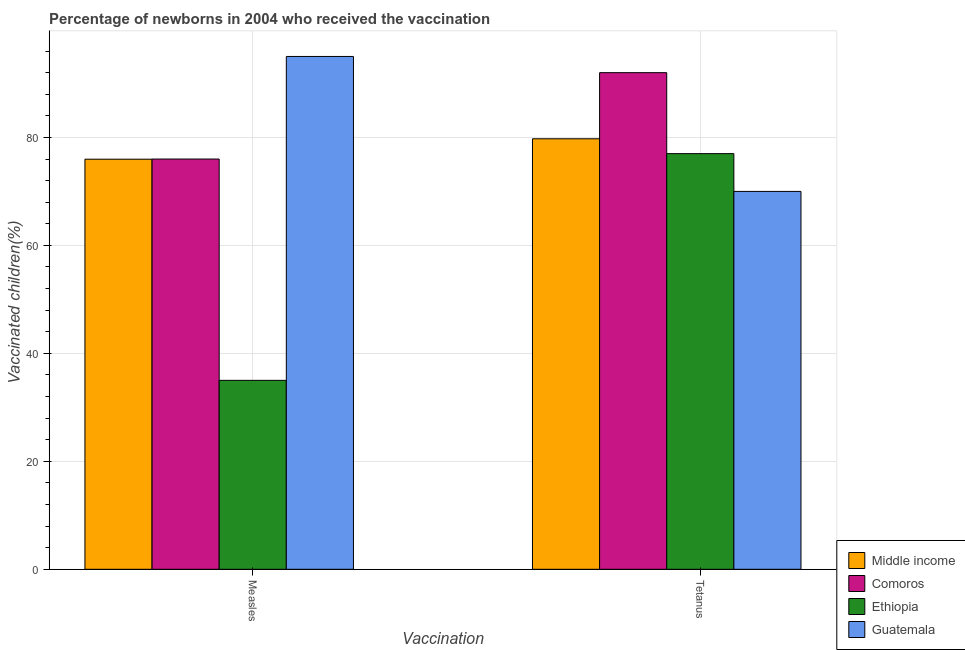How many groups of bars are there?
Your answer should be very brief. 2. Are the number of bars per tick equal to the number of legend labels?
Offer a terse response. Yes. What is the label of the 2nd group of bars from the left?
Your answer should be compact. Tetanus. What is the percentage of newborns who received vaccination for tetanus in Guatemala?
Offer a terse response. 70. Across all countries, what is the maximum percentage of newborns who received vaccination for tetanus?
Provide a short and direct response. 92. Across all countries, what is the minimum percentage of newborns who received vaccination for measles?
Provide a succinct answer. 35. In which country was the percentage of newborns who received vaccination for tetanus maximum?
Offer a very short reply. Comoros. In which country was the percentage of newborns who received vaccination for measles minimum?
Your answer should be very brief. Ethiopia. What is the total percentage of newborns who received vaccination for measles in the graph?
Provide a short and direct response. 281.97. What is the difference between the percentage of newborns who received vaccination for measles in Guatemala and that in Ethiopia?
Ensure brevity in your answer.  60. What is the difference between the percentage of newborns who received vaccination for tetanus in Comoros and the percentage of newborns who received vaccination for measles in Middle income?
Provide a succinct answer. 16.03. What is the average percentage of newborns who received vaccination for tetanus per country?
Keep it short and to the point. 79.69. In how many countries, is the percentage of newborns who received vaccination for tetanus greater than 36 %?
Offer a terse response. 4. What is the ratio of the percentage of newborns who received vaccination for measles in Ethiopia to that in Guatemala?
Provide a short and direct response. 0.37. Is the percentage of newborns who received vaccination for tetanus in Ethiopia less than that in Middle income?
Your answer should be very brief. Yes. In how many countries, is the percentage of newborns who received vaccination for measles greater than the average percentage of newborns who received vaccination for measles taken over all countries?
Provide a short and direct response. 3. What does the 3rd bar from the right in Tetanus represents?
Provide a short and direct response. Comoros. How many bars are there?
Provide a short and direct response. 8. How many countries are there in the graph?
Keep it short and to the point. 4. What is the difference between two consecutive major ticks on the Y-axis?
Offer a terse response. 20. Does the graph contain grids?
Make the answer very short. Yes. Where does the legend appear in the graph?
Make the answer very short. Bottom right. How many legend labels are there?
Ensure brevity in your answer.  4. What is the title of the graph?
Give a very brief answer. Percentage of newborns in 2004 who received the vaccination. Does "European Union" appear as one of the legend labels in the graph?
Give a very brief answer. No. What is the label or title of the X-axis?
Offer a very short reply. Vaccination. What is the label or title of the Y-axis?
Your answer should be compact. Vaccinated children(%)
. What is the Vaccinated children(%)
 of Middle income in Measles?
Ensure brevity in your answer.  75.97. What is the Vaccinated children(%)
 in Comoros in Measles?
Provide a short and direct response. 76. What is the Vaccinated children(%)
 in Ethiopia in Measles?
Provide a succinct answer. 35. What is the Vaccinated children(%)
 of Guatemala in Measles?
Your answer should be very brief. 95. What is the Vaccinated children(%)
 in Middle income in Tetanus?
Provide a succinct answer. 79.75. What is the Vaccinated children(%)
 in Comoros in Tetanus?
Offer a very short reply. 92. What is the Vaccinated children(%)
 of Ethiopia in Tetanus?
Your answer should be compact. 77. Across all Vaccination, what is the maximum Vaccinated children(%)
 of Middle income?
Offer a terse response. 79.75. Across all Vaccination, what is the maximum Vaccinated children(%)
 in Comoros?
Give a very brief answer. 92. Across all Vaccination, what is the maximum Vaccinated children(%)
 in Guatemala?
Keep it short and to the point. 95. Across all Vaccination, what is the minimum Vaccinated children(%)
 of Middle income?
Keep it short and to the point. 75.97. What is the total Vaccinated children(%)
 of Middle income in the graph?
Your answer should be compact. 155.72. What is the total Vaccinated children(%)
 of Comoros in the graph?
Your answer should be very brief. 168. What is the total Vaccinated children(%)
 of Ethiopia in the graph?
Your response must be concise. 112. What is the total Vaccinated children(%)
 in Guatemala in the graph?
Ensure brevity in your answer.  165. What is the difference between the Vaccinated children(%)
 in Middle income in Measles and that in Tetanus?
Your answer should be compact. -3.78. What is the difference between the Vaccinated children(%)
 of Ethiopia in Measles and that in Tetanus?
Offer a terse response. -42. What is the difference between the Vaccinated children(%)
 in Middle income in Measles and the Vaccinated children(%)
 in Comoros in Tetanus?
Your answer should be compact. -16.03. What is the difference between the Vaccinated children(%)
 of Middle income in Measles and the Vaccinated children(%)
 of Ethiopia in Tetanus?
Make the answer very short. -1.03. What is the difference between the Vaccinated children(%)
 of Middle income in Measles and the Vaccinated children(%)
 of Guatemala in Tetanus?
Your response must be concise. 5.97. What is the difference between the Vaccinated children(%)
 of Ethiopia in Measles and the Vaccinated children(%)
 of Guatemala in Tetanus?
Your answer should be very brief. -35. What is the average Vaccinated children(%)
 of Middle income per Vaccination?
Ensure brevity in your answer.  77.86. What is the average Vaccinated children(%)
 in Guatemala per Vaccination?
Offer a very short reply. 82.5. What is the difference between the Vaccinated children(%)
 in Middle income and Vaccinated children(%)
 in Comoros in Measles?
Offer a very short reply. -0.03. What is the difference between the Vaccinated children(%)
 in Middle income and Vaccinated children(%)
 in Ethiopia in Measles?
Your answer should be compact. 40.97. What is the difference between the Vaccinated children(%)
 in Middle income and Vaccinated children(%)
 in Guatemala in Measles?
Ensure brevity in your answer.  -19.03. What is the difference between the Vaccinated children(%)
 of Ethiopia and Vaccinated children(%)
 of Guatemala in Measles?
Offer a very short reply. -60. What is the difference between the Vaccinated children(%)
 of Middle income and Vaccinated children(%)
 of Comoros in Tetanus?
Provide a succinct answer. -12.25. What is the difference between the Vaccinated children(%)
 in Middle income and Vaccinated children(%)
 in Ethiopia in Tetanus?
Provide a succinct answer. 2.75. What is the difference between the Vaccinated children(%)
 in Middle income and Vaccinated children(%)
 in Guatemala in Tetanus?
Keep it short and to the point. 9.75. What is the difference between the Vaccinated children(%)
 in Comoros and Vaccinated children(%)
 in Guatemala in Tetanus?
Provide a short and direct response. 22. What is the difference between the Vaccinated children(%)
 in Ethiopia and Vaccinated children(%)
 in Guatemala in Tetanus?
Offer a terse response. 7. What is the ratio of the Vaccinated children(%)
 of Middle income in Measles to that in Tetanus?
Your answer should be very brief. 0.95. What is the ratio of the Vaccinated children(%)
 in Comoros in Measles to that in Tetanus?
Offer a very short reply. 0.83. What is the ratio of the Vaccinated children(%)
 of Ethiopia in Measles to that in Tetanus?
Provide a succinct answer. 0.45. What is the ratio of the Vaccinated children(%)
 of Guatemala in Measles to that in Tetanus?
Ensure brevity in your answer.  1.36. What is the difference between the highest and the second highest Vaccinated children(%)
 of Middle income?
Offer a terse response. 3.78. What is the difference between the highest and the second highest Vaccinated children(%)
 in Comoros?
Your answer should be very brief. 16. What is the difference between the highest and the lowest Vaccinated children(%)
 in Middle income?
Offer a very short reply. 3.78. What is the difference between the highest and the lowest Vaccinated children(%)
 of Ethiopia?
Provide a short and direct response. 42. 